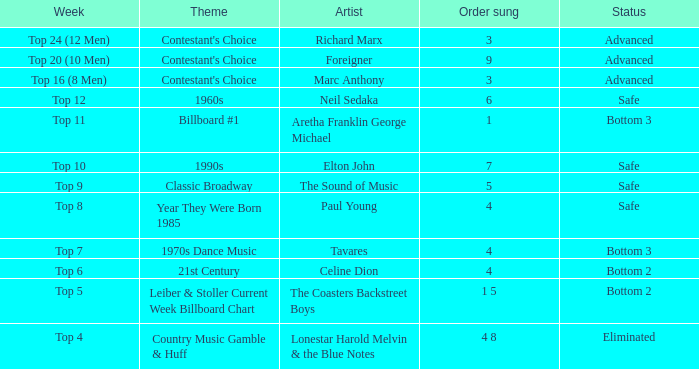What order was the performance of a Richard Marx song? 3.0. 